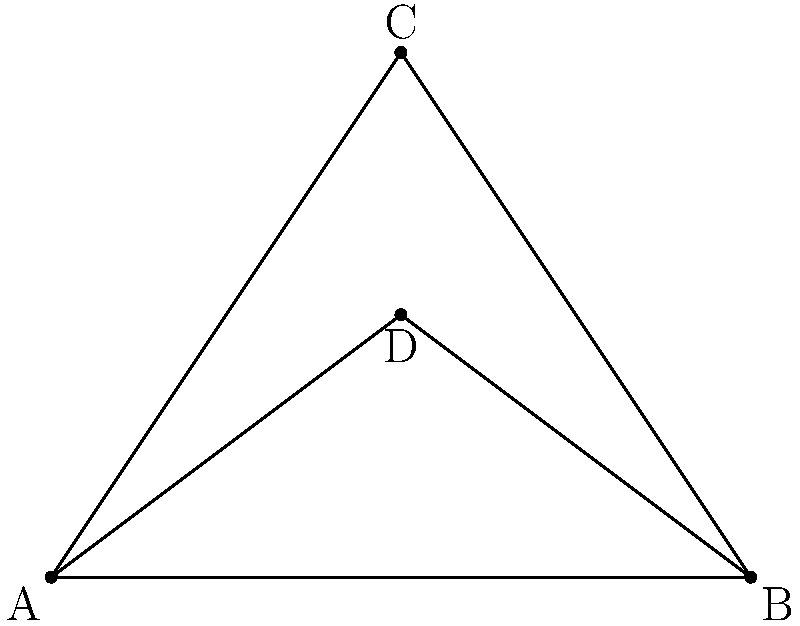The iconic AfroPunk festival stage is shaped like a triangle with a platform in the middle, as shown in the diagram. If the base of the stage (AB) is 8 meters long and the height (CD) is 3 meters, what is the area of the entire triangular stage (ABC)? Let's approach this step-by-step:

1) The shape we're dealing with is a triangle. We know the base (b) and the height (h) of this triangle.

2) The formula for the area of a triangle is:

   $$ A = \frac{1}{2} \times b \times h $$

3) We know:
   - Base (AB) = 8 meters
   - Height (CD) = 3 meters

4) Let's substitute these values into our formula:

   $$ A = \frac{1}{2} \times 8 \times 3 $$

5) Now, let's calculate:

   $$ A = \frac{1}{2} \times 24 = 12 $$

6) Therefore, the area of the triangular stage is 12 square meters.
Answer: 12 m² 